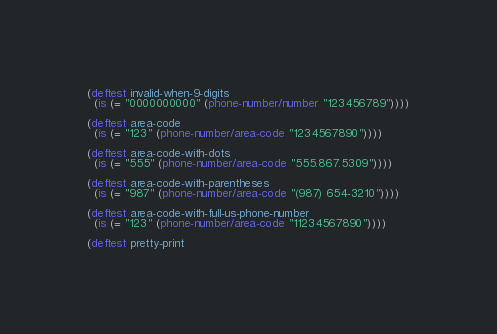<code> <loc_0><loc_0><loc_500><loc_500><_Clojure_>
(deftest invalid-when-9-digits
  (is (= "0000000000" (phone-number/number "123456789"))))

(deftest area-code
  (is (= "123" (phone-number/area-code "1234567890"))))

(deftest area-code-with-dots
  (is (= "555" (phone-number/area-code "555.867.5309"))))

(deftest area-code-with-parentheses
  (is (= "987" (phone-number/area-code "(987) 654-3210"))))

(deftest area-code-with-full-us-phone-number
  (is (= "123" (phone-number/area-code "11234567890"))))

(deftest pretty-print</code> 